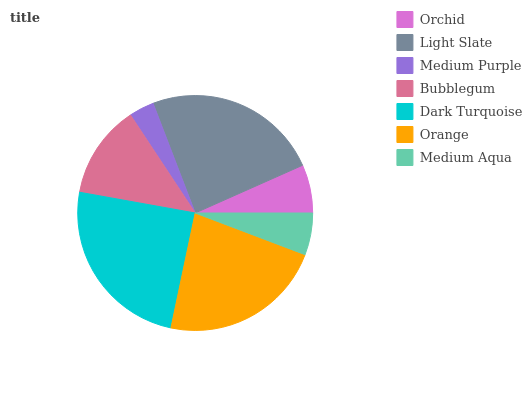Is Medium Purple the minimum?
Answer yes or no. Yes. Is Dark Turquoise the maximum?
Answer yes or no. Yes. Is Light Slate the minimum?
Answer yes or no. No. Is Light Slate the maximum?
Answer yes or no. No. Is Light Slate greater than Orchid?
Answer yes or no. Yes. Is Orchid less than Light Slate?
Answer yes or no. Yes. Is Orchid greater than Light Slate?
Answer yes or no. No. Is Light Slate less than Orchid?
Answer yes or no. No. Is Bubblegum the high median?
Answer yes or no. Yes. Is Bubblegum the low median?
Answer yes or no. Yes. Is Medium Aqua the high median?
Answer yes or no. No. Is Light Slate the low median?
Answer yes or no. No. 